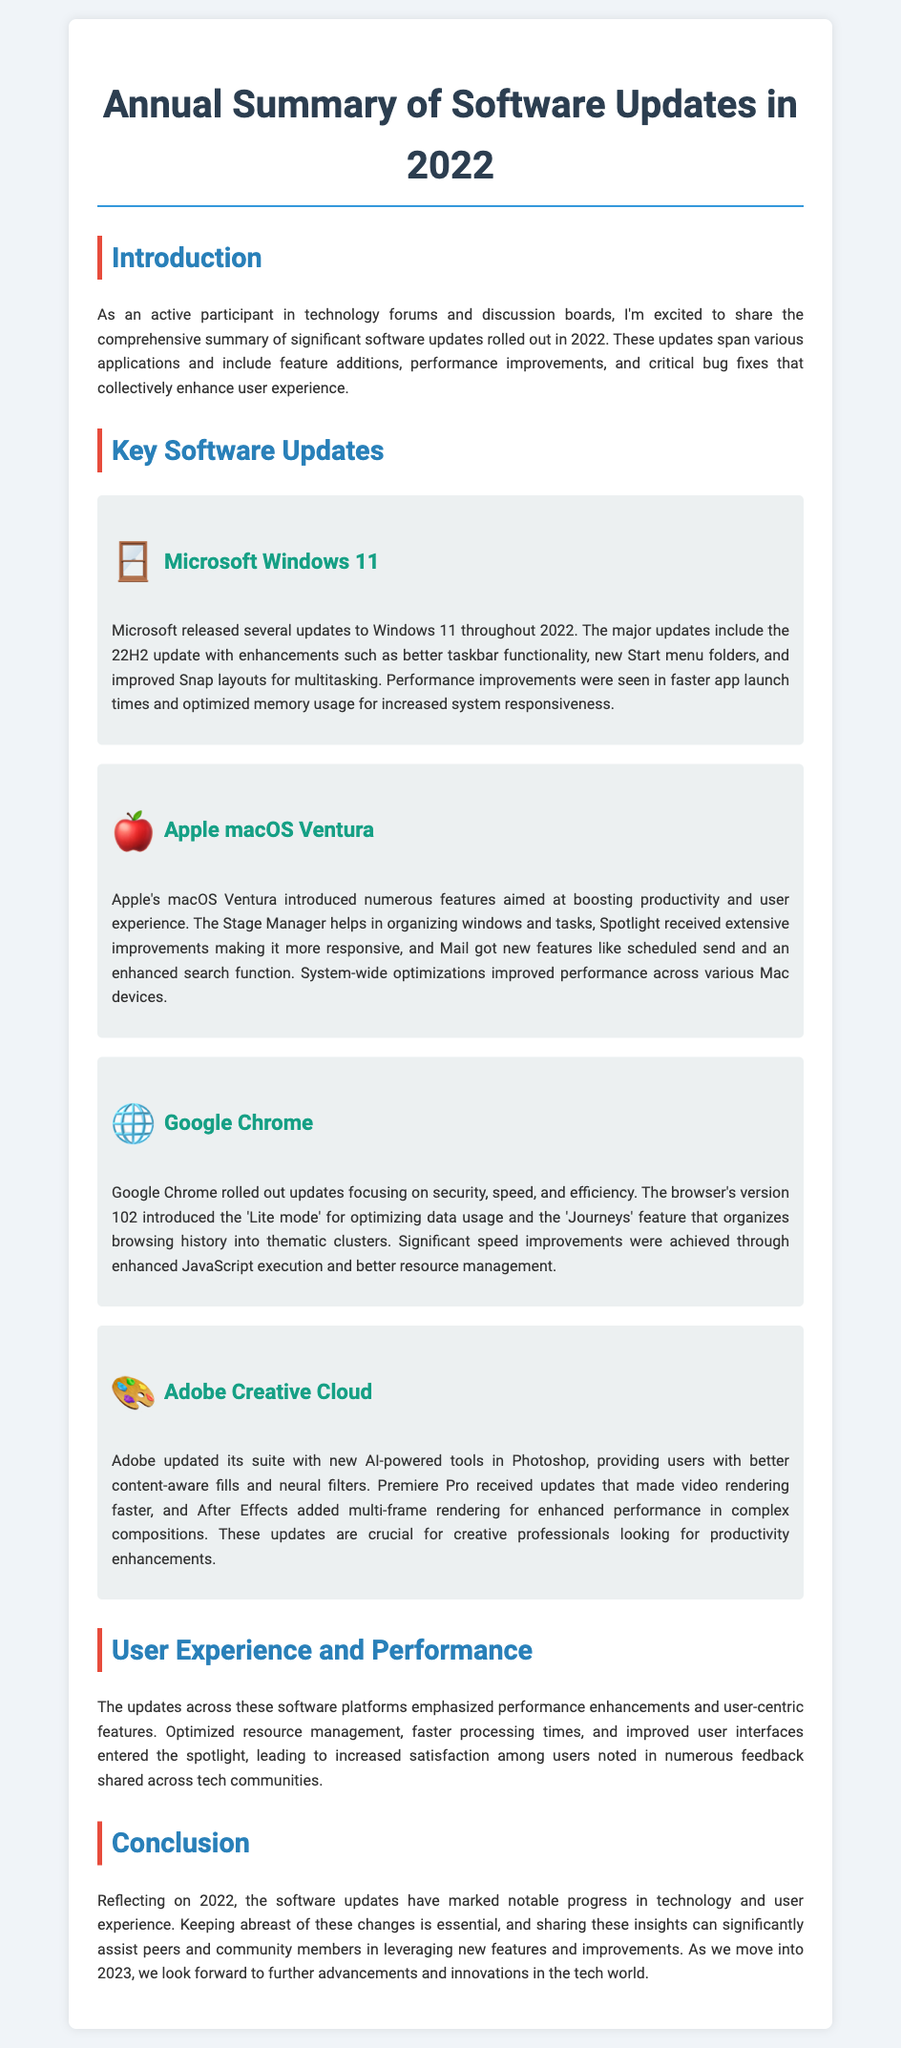What is the year of the software updates discussed? The document summarizes software updates that occurred in 2022.
Answer: 2022 Which operating system received the 22H2 update? The 22H2 update was released for Microsoft Windows 11.
Answer: Microsoft Windows 11 What feature helps organize windows in macOS Ventura? The Stage Manager is a feature that helps organize windows in macOS Ventura.
Answer: Stage Manager Which version of Google Chrome introduced the 'Lite mode'? The 'Lite mode' was introduced in Google Chrome version 102.
Answer: version 102 What kind of tools were newly added in Adobe Photoshop? AI-powered tools were added to Photoshop, enhancing content-aware fills and neural filters.
Answer: AI-powered tools How are performance improvements across software platforms characterized? Performance improvements emphasized optimized resource management and faster processing times.
Answer: Optimized resource management and faster processing times What was a key aspect noted in user feedback regarding 2022 updates? Increased satisfaction among users was noted in feedback shared across tech communities.
Answer: Increased satisfaction What is the main goal of sharing the insights from the document? The main goal is to assist peers and community members in leveraging new features and improvements.
Answer: Assist peers and community members How does the document structure its content? The document is structured into sections such as Introduction, Key Software Updates, User Experience, and Conclusion.
Answer: Sections 